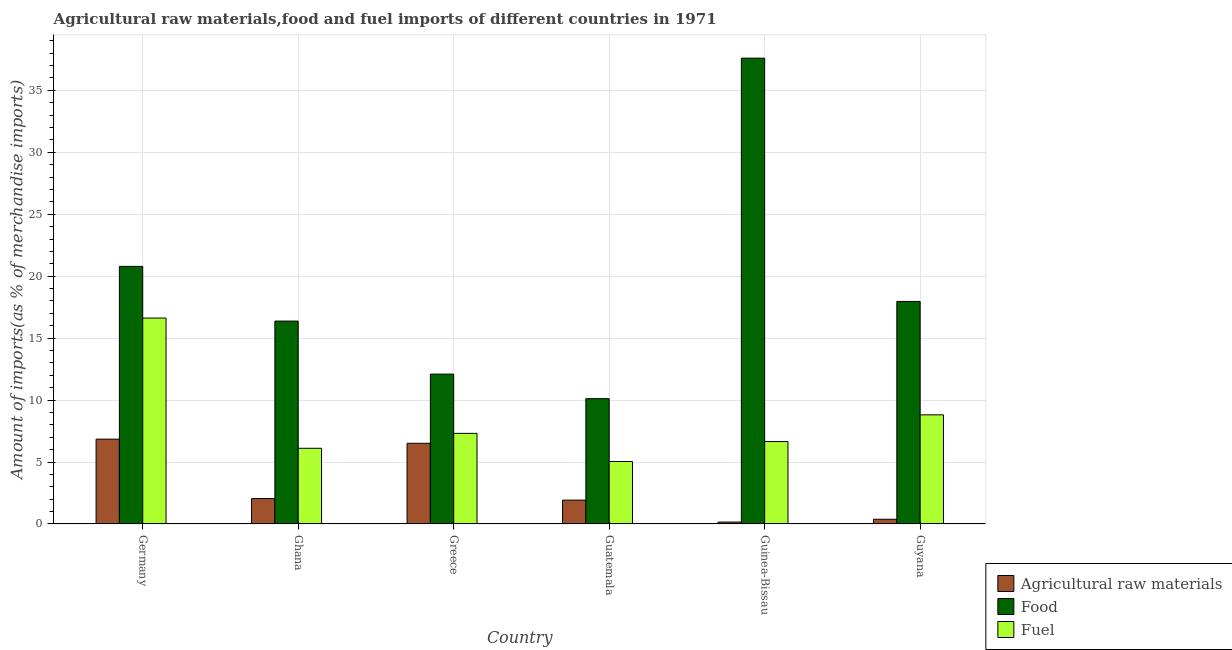How many bars are there on the 3rd tick from the left?
Give a very brief answer. 3. What is the label of the 2nd group of bars from the left?
Offer a very short reply. Ghana. What is the percentage of food imports in Guatemala?
Offer a terse response. 10.11. Across all countries, what is the maximum percentage of raw materials imports?
Offer a terse response. 6.85. Across all countries, what is the minimum percentage of fuel imports?
Your response must be concise. 5.04. In which country was the percentage of fuel imports maximum?
Keep it short and to the point. Germany. In which country was the percentage of fuel imports minimum?
Make the answer very short. Guatemala. What is the total percentage of food imports in the graph?
Make the answer very short. 114.93. What is the difference between the percentage of food imports in Ghana and that in Guinea-Bissau?
Ensure brevity in your answer.  -21.22. What is the difference between the percentage of raw materials imports in Ghana and the percentage of food imports in Guinea-Bissau?
Keep it short and to the point. -35.54. What is the average percentage of raw materials imports per country?
Ensure brevity in your answer.  2.98. What is the difference between the percentage of raw materials imports and percentage of food imports in Guinea-Bissau?
Offer a very short reply. -37.44. What is the ratio of the percentage of food imports in Guatemala to that in Guinea-Bissau?
Your answer should be compact. 0.27. Is the percentage of food imports in Guatemala less than that in Guyana?
Keep it short and to the point. Yes. What is the difference between the highest and the second highest percentage of food imports?
Keep it short and to the point. 16.81. What is the difference between the highest and the lowest percentage of fuel imports?
Provide a short and direct response. 11.58. In how many countries, is the percentage of fuel imports greater than the average percentage of fuel imports taken over all countries?
Give a very brief answer. 2. Is the sum of the percentage of fuel imports in Germany and Guyana greater than the maximum percentage of raw materials imports across all countries?
Offer a very short reply. Yes. What does the 2nd bar from the left in Greece represents?
Provide a succinct answer. Food. What does the 2nd bar from the right in Guyana represents?
Ensure brevity in your answer.  Food. How many bars are there?
Provide a succinct answer. 18. Are all the bars in the graph horizontal?
Offer a very short reply. No. How many countries are there in the graph?
Offer a terse response. 6. Does the graph contain grids?
Provide a succinct answer. Yes. How many legend labels are there?
Offer a very short reply. 3. How are the legend labels stacked?
Offer a very short reply. Vertical. What is the title of the graph?
Your answer should be very brief. Agricultural raw materials,food and fuel imports of different countries in 1971. Does "Profit Tax" appear as one of the legend labels in the graph?
Provide a succinct answer. No. What is the label or title of the X-axis?
Your response must be concise. Country. What is the label or title of the Y-axis?
Ensure brevity in your answer.  Amount of imports(as % of merchandise imports). What is the Amount of imports(as % of merchandise imports) of Agricultural raw materials in Germany?
Offer a terse response. 6.85. What is the Amount of imports(as % of merchandise imports) in Food in Germany?
Make the answer very short. 20.79. What is the Amount of imports(as % of merchandise imports) of Fuel in Germany?
Your answer should be compact. 16.62. What is the Amount of imports(as % of merchandise imports) of Agricultural raw materials in Ghana?
Provide a short and direct response. 2.05. What is the Amount of imports(as % of merchandise imports) in Food in Ghana?
Your answer should be compact. 16.38. What is the Amount of imports(as % of merchandise imports) in Fuel in Ghana?
Your response must be concise. 6.11. What is the Amount of imports(as % of merchandise imports) in Agricultural raw materials in Greece?
Provide a short and direct response. 6.51. What is the Amount of imports(as % of merchandise imports) in Food in Greece?
Provide a short and direct response. 12.09. What is the Amount of imports(as % of merchandise imports) in Fuel in Greece?
Ensure brevity in your answer.  7.31. What is the Amount of imports(as % of merchandise imports) in Agricultural raw materials in Guatemala?
Offer a terse response. 1.93. What is the Amount of imports(as % of merchandise imports) of Food in Guatemala?
Ensure brevity in your answer.  10.11. What is the Amount of imports(as % of merchandise imports) of Fuel in Guatemala?
Provide a succinct answer. 5.04. What is the Amount of imports(as % of merchandise imports) of Agricultural raw materials in Guinea-Bissau?
Provide a succinct answer. 0.15. What is the Amount of imports(as % of merchandise imports) of Food in Guinea-Bissau?
Make the answer very short. 37.6. What is the Amount of imports(as % of merchandise imports) in Fuel in Guinea-Bissau?
Give a very brief answer. 6.65. What is the Amount of imports(as % of merchandise imports) in Agricultural raw materials in Guyana?
Provide a succinct answer. 0.38. What is the Amount of imports(as % of merchandise imports) in Food in Guyana?
Keep it short and to the point. 17.96. What is the Amount of imports(as % of merchandise imports) of Fuel in Guyana?
Your response must be concise. 8.81. Across all countries, what is the maximum Amount of imports(as % of merchandise imports) of Agricultural raw materials?
Make the answer very short. 6.85. Across all countries, what is the maximum Amount of imports(as % of merchandise imports) of Food?
Provide a succinct answer. 37.6. Across all countries, what is the maximum Amount of imports(as % of merchandise imports) in Fuel?
Ensure brevity in your answer.  16.62. Across all countries, what is the minimum Amount of imports(as % of merchandise imports) in Agricultural raw materials?
Offer a very short reply. 0.15. Across all countries, what is the minimum Amount of imports(as % of merchandise imports) in Food?
Make the answer very short. 10.11. Across all countries, what is the minimum Amount of imports(as % of merchandise imports) of Fuel?
Your response must be concise. 5.04. What is the total Amount of imports(as % of merchandise imports) of Agricultural raw materials in the graph?
Give a very brief answer. 17.87. What is the total Amount of imports(as % of merchandise imports) in Food in the graph?
Make the answer very short. 114.93. What is the total Amount of imports(as % of merchandise imports) in Fuel in the graph?
Your answer should be very brief. 50.55. What is the difference between the Amount of imports(as % of merchandise imports) in Agricultural raw materials in Germany and that in Ghana?
Ensure brevity in your answer.  4.8. What is the difference between the Amount of imports(as % of merchandise imports) of Food in Germany and that in Ghana?
Provide a succinct answer. 4.41. What is the difference between the Amount of imports(as % of merchandise imports) of Fuel in Germany and that in Ghana?
Offer a very short reply. 10.51. What is the difference between the Amount of imports(as % of merchandise imports) in Agricultural raw materials in Germany and that in Greece?
Offer a terse response. 0.34. What is the difference between the Amount of imports(as % of merchandise imports) of Food in Germany and that in Greece?
Give a very brief answer. 8.7. What is the difference between the Amount of imports(as % of merchandise imports) in Fuel in Germany and that in Greece?
Ensure brevity in your answer.  9.31. What is the difference between the Amount of imports(as % of merchandise imports) of Agricultural raw materials in Germany and that in Guatemala?
Give a very brief answer. 4.92. What is the difference between the Amount of imports(as % of merchandise imports) of Food in Germany and that in Guatemala?
Your answer should be very brief. 10.68. What is the difference between the Amount of imports(as % of merchandise imports) in Fuel in Germany and that in Guatemala?
Ensure brevity in your answer.  11.58. What is the difference between the Amount of imports(as % of merchandise imports) of Agricultural raw materials in Germany and that in Guinea-Bissau?
Provide a short and direct response. 6.69. What is the difference between the Amount of imports(as % of merchandise imports) of Food in Germany and that in Guinea-Bissau?
Provide a short and direct response. -16.81. What is the difference between the Amount of imports(as % of merchandise imports) of Fuel in Germany and that in Guinea-Bissau?
Your answer should be compact. 9.97. What is the difference between the Amount of imports(as % of merchandise imports) of Agricultural raw materials in Germany and that in Guyana?
Ensure brevity in your answer.  6.47. What is the difference between the Amount of imports(as % of merchandise imports) of Food in Germany and that in Guyana?
Provide a short and direct response. 2.83. What is the difference between the Amount of imports(as % of merchandise imports) in Fuel in Germany and that in Guyana?
Your answer should be very brief. 7.81. What is the difference between the Amount of imports(as % of merchandise imports) in Agricultural raw materials in Ghana and that in Greece?
Give a very brief answer. -4.46. What is the difference between the Amount of imports(as % of merchandise imports) of Food in Ghana and that in Greece?
Offer a very short reply. 4.28. What is the difference between the Amount of imports(as % of merchandise imports) in Fuel in Ghana and that in Greece?
Provide a succinct answer. -1.2. What is the difference between the Amount of imports(as % of merchandise imports) of Agricultural raw materials in Ghana and that in Guatemala?
Provide a short and direct response. 0.13. What is the difference between the Amount of imports(as % of merchandise imports) of Food in Ghana and that in Guatemala?
Give a very brief answer. 6.26. What is the difference between the Amount of imports(as % of merchandise imports) of Fuel in Ghana and that in Guatemala?
Your answer should be compact. 1.07. What is the difference between the Amount of imports(as % of merchandise imports) in Agricultural raw materials in Ghana and that in Guinea-Bissau?
Your answer should be compact. 1.9. What is the difference between the Amount of imports(as % of merchandise imports) in Food in Ghana and that in Guinea-Bissau?
Your response must be concise. -21.22. What is the difference between the Amount of imports(as % of merchandise imports) of Fuel in Ghana and that in Guinea-Bissau?
Keep it short and to the point. -0.54. What is the difference between the Amount of imports(as % of merchandise imports) in Agricultural raw materials in Ghana and that in Guyana?
Make the answer very short. 1.67. What is the difference between the Amount of imports(as % of merchandise imports) of Food in Ghana and that in Guyana?
Give a very brief answer. -1.59. What is the difference between the Amount of imports(as % of merchandise imports) of Fuel in Ghana and that in Guyana?
Keep it short and to the point. -2.7. What is the difference between the Amount of imports(as % of merchandise imports) in Agricultural raw materials in Greece and that in Guatemala?
Your answer should be very brief. 4.59. What is the difference between the Amount of imports(as % of merchandise imports) in Food in Greece and that in Guatemala?
Offer a very short reply. 1.98. What is the difference between the Amount of imports(as % of merchandise imports) of Fuel in Greece and that in Guatemala?
Provide a short and direct response. 2.27. What is the difference between the Amount of imports(as % of merchandise imports) in Agricultural raw materials in Greece and that in Guinea-Bissau?
Offer a very short reply. 6.36. What is the difference between the Amount of imports(as % of merchandise imports) of Food in Greece and that in Guinea-Bissau?
Keep it short and to the point. -25.5. What is the difference between the Amount of imports(as % of merchandise imports) in Fuel in Greece and that in Guinea-Bissau?
Keep it short and to the point. 0.66. What is the difference between the Amount of imports(as % of merchandise imports) of Agricultural raw materials in Greece and that in Guyana?
Ensure brevity in your answer.  6.13. What is the difference between the Amount of imports(as % of merchandise imports) in Food in Greece and that in Guyana?
Provide a short and direct response. -5.87. What is the difference between the Amount of imports(as % of merchandise imports) of Fuel in Greece and that in Guyana?
Make the answer very short. -1.5. What is the difference between the Amount of imports(as % of merchandise imports) of Agricultural raw materials in Guatemala and that in Guinea-Bissau?
Your answer should be very brief. 1.77. What is the difference between the Amount of imports(as % of merchandise imports) of Food in Guatemala and that in Guinea-Bissau?
Give a very brief answer. -27.48. What is the difference between the Amount of imports(as % of merchandise imports) in Fuel in Guatemala and that in Guinea-Bissau?
Ensure brevity in your answer.  -1.61. What is the difference between the Amount of imports(as % of merchandise imports) of Agricultural raw materials in Guatemala and that in Guyana?
Your response must be concise. 1.55. What is the difference between the Amount of imports(as % of merchandise imports) in Food in Guatemala and that in Guyana?
Provide a succinct answer. -7.85. What is the difference between the Amount of imports(as % of merchandise imports) of Fuel in Guatemala and that in Guyana?
Make the answer very short. -3.77. What is the difference between the Amount of imports(as % of merchandise imports) of Agricultural raw materials in Guinea-Bissau and that in Guyana?
Your response must be concise. -0.23. What is the difference between the Amount of imports(as % of merchandise imports) in Food in Guinea-Bissau and that in Guyana?
Your answer should be very brief. 19.63. What is the difference between the Amount of imports(as % of merchandise imports) of Fuel in Guinea-Bissau and that in Guyana?
Your answer should be very brief. -2.16. What is the difference between the Amount of imports(as % of merchandise imports) of Agricultural raw materials in Germany and the Amount of imports(as % of merchandise imports) of Food in Ghana?
Your response must be concise. -9.53. What is the difference between the Amount of imports(as % of merchandise imports) in Agricultural raw materials in Germany and the Amount of imports(as % of merchandise imports) in Fuel in Ghana?
Offer a very short reply. 0.74. What is the difference between the Amount of imports(as % of merchandise imports) in Food in Germany and the Amount of imports(as % of merchandise imports) in Fuel in Ghana?
Give a very brief answer. 14.68. What is the difference between the Amount of imports(as % of merchandise imports) in Agricultural raw materials in Germany and the Amount of imports(as % of merchandise imports) in Food in Greece?
Make the answer very short. -5.25. What is the difference between the Amount of imports(as % of merchandise imports) of Agricultural raw materials in Germany and the Amount of imports(as % of merchandise imports) of Fuel in Greece?
Your answer should be compact. -0.47. What is the difference between the Amount of imports(as % of merchandise imports) of Food in Germany and the Amount of imports(as % of merchandise imports) of Fuel in Greece?
Give a very brief answer. 13.48. What is the difference between the Amount of imports(as % of merchandise imports) of Agricultural raw materials in Germany and the Amount of imports(as % of merchandise imports) of Food in Guatemala?
Provide a short and direct response. -3.27. What is the difference between the Amount of imports(as % of merchandise imports) in Agricultural raw materials in Germany and the Amount of imports(as % of merchandise imports) in Fuel in Guatemala?
Make the answer very short. 1.8. What is the difference between the Amount of imports(as % of merchandise imports) in Food in Germany and the Amount of imports(as % of merchandise imports) in Fuel in Guatemala?
Offer a very short reply. 15.75. What is the difference between the Amount of imports(as % of merchandise imports) in Agricultural raw materials in Germany and the Amount of imports(as % of merchandise imports) in Food in Guinea-Bissau?
Offer a very short reply. -30.75. What is the difference between the Amount of imports(as % of merchandise imports) of Agricultural raw materials in Germany and the Amount of imports(as % of merchandise imports) of Fuel in Guinea-Bissau?
Offer a terse response. 0.19. What is the difference between the Amount of imports(as % of merchandise imports) of Food in Germany and the Amount of imports(as % of merchandise imports) of Fuel in Guinea-Bissau?
Offer a terse response. 14.14. What is the difference between the Amount of imports(as % of merchandise imports) of Agricultural raw materials in Germany and the Amount of imports(as % of merchandise imports) of Food in Guyana?
Provide a succinct answer. -11.11. What is the difference between the Amount of imports(as % of merchandise imports) in Agricultural raw materials in Germany and the Amount of imports(as % of merchandise imports) in Fuel in Guyana?
Offer a terse response. -1.96. What is the difference between the Amount of imports(as % of merchandise imports) of Food in Germany and the Amount of imports(as % of merchandise imports) of Fuel in Guyana?
Keep it short and to the point. 11.98. What is the difference between the Amount of imports(as % of merchandise imports) of Agricultural raw materials in Ghana and the Amount of imports(as % of merchandise imports) of Food in Greece?
Ensure brevity in your answer.  -10.04. What is the difference between the Amount of imports(as % of merchandise imports) in Agricultural raw materials in Ghana and the Amount of imports(as % of merchandise imports) in Fuel in Greece?
Give a very brief answer. -5.26. What is the difference between the Amount of imports(as % of merchandise imports) of Food in Ghana and the Amount of imports(as % of merchandise imports) of Fuel in Greece?
Your answer should be very brief. 9.06. What is the difference between the Amount of imports(as % of merchandise imports) in Agricultural raw materials in Ghana and the Amount of imports(as % of merchandise imports) in Food in Guatemala?
Keep it short and to the point. -8.06. What is the difference between the Amount of imports(as % of merchandise imports) of Agricultural raw materials in Ghana and the Amount of imports(as % of merchandise imports) of Fuel in Guatemala?
Your response must be concise. -2.99. What is the difference between the Amount of imports(as % of merchandise imports) of Food in Ghana and the Amount of imports(as % of merchandise imports) of Fuel in Guatemala?
Offer a terse response. 11.33. What is the difference between the Amount of imports(as % of merchandise imports) of Agricultural raw materials in Ghana and the Amount of imports(as % of merchandise imports) of Food in Guinea-Bissau?
Offer a terse response. -35.54. What is the difference between the Amount of imports(as % of merchandise imports) in Agricultural raw materials in Ghana and the Amount of imports(as % of merchandise imports) in Fuel in Guinea-Bissau?
Offer a very short reply. -4.6. What is the difference between the Amount of imports(as % of merchandise imports) of Food in Ghana and the Amount of imports(as % of merchandise imports) of Fuel in Guinea-Bissau?
Provide a succinct answer. 9.72. What is the difference between the Amount of imports(as % of merchandise imports) in Agricultural raw materials in Ghana and the Amount of imports(as % of merchandise imports) in Food in Guyana?
Provide a short and direct response. -15.91. What is the difference between the Amount of imports(as % of merchandise imports) in Agricultural raw materials in Ghana and the Amount of imports(as % of merchandise imports) in Fuel in Guyana?
Your answer should be compact. -6.76. What is the difference between the Amount of imports(as % of merchandise imports) in Food in Ghana and the Amount of imports(as % of merchandise imports) in Fuel in Guyana?
Your response must be concise. 7.57. What is the difference between the Amount of imports(as % of merchandise imports) in Agricultural raw materials in Greece and the Amount of imports(as % of merchandise imports) in Food in Guatemala?
Keep it short and to the point. -3.6. What is the difference between the Amount of imports(as % of merchandise imports) of Agricultural raw materials in Greece and the Amount of imports(as % of merchandise imports) of Fuel in Guatemala?
Your answer should be compact. 1.47. What is the difference between the Amount of imports(as % of merchandise imports) in Food in Greece and the Amount of imports(as % of merchandise imports) in Fuel in Guatemala?
Offer a very short reply. 7.05. What is the difference between the Amount of imports(as % of merchandise imports) in Agricultural raw materials in Greece and the Amount of imports(as % of merchandise imports) in Food in Guinea-Bissau?
Give a very brief answer. -31.08. What is the difference between the Amount of imports(as % of merchandise imports) in Agricultural raw materials in Greece and the Amount of imports(as % of merchandise imports) in Fuel in Guinea-Bissau?
Keep it short and to the point. -0.14. What is the difference between the Amount of imports(as % of merchandise imports) of Food in Greece and the Amount of imports(as % of merchandise imports) of Fuel in Guinea-Bissau?
Offer a terse response. 5.44. What is the difference between the Amount of imports(as % of merchandise imports) in Agricultural raw materials in Greece and the Amount of imports(as % of merchandise imports) in Food in Guyana?
Offer a very short reply. -11.45. What is the difference between the Amount of imports(as % of merchandise imports) in Agricultural raw materials in Greece and the Amount of imports(as % of merchandise imports) in Fuel in Guyana?
Your response must be concise. -2.3. What is the difference between the Amount of imports(as % of merchandise imports) of Food in Greece and the Amount of imports(as % of merchandise imports) of Fuel in Guyana?
Make the answer very short. 3.29. What is the difference between the Amount of imports(as % of merchandise imports) in Agricultural raw materials in Guatemala and the Amount of imports(as % of merchandise imports) in Food in Guinea-Bissau?
Keep it short and to the point. -35.67. What is the difference between the Amount of imports(as % of merchandise imports) of Agricultural raw materials in Guatemala and the Amount of imports(as % of merchandise imports) of Fuel in Guinea-Bissau?
Your answer should be compact. -4.73. What is the difference between the Amount of imports(as % of merchandise imports) in Food in Guatemala and the Amount of imports(as % of merchandise imports) in Fuel in Guinea-Bissau?
Your answer should be very brief. 3.46. What is the difference between the Amount of imports(as % of merchandise imports) in Agricultural raw materials in Guatemala and the Amount of imports(as % of merchandise imports) in Food in Guyana?
Give a very brief answer. -16.04. What is the difference between the Amount of imports(as % of merchandise imports) in Agricultural raw materials in Guatemala and the Amount of imports(as % of merchandise imports) in Fuel in Guyana?
Your response must be concise. -6.88. What is the difference between the Amount of imports(as % of merchandise imports) in Food in Guatemala and the Amount of imports(as % of merchandise imports) in Fuel in Guyana?
Provide a succinct answer. 1.3. What is the difference between the Amount of imports(as % of merchandise imports) in Agricultural raw materials in Guinea-Bissau and the Amount of imports(as % of merchandise imports) in Food in Guyana?
Give a very brief answer. -17.81. What is the difference between the Amount of imports(as % of merchandise imports) of Agricultural raw materials in Guinea-Bissau and the Amount of imports(as % of merchandise imports) of Fuel in Guyana?
Keep it short and to the point. -8.65. What is the difference between the Amount of imports(as % of merchandise imports) of Food in Guinea-Bissau and the Amount of imports(as % of merchandise imports) of Fuel in Guyana?
Provide a short and direct response. 28.79. What is the average Amount of imports(as % of merchandise imports) of Agricultural raw materials per country?
Provide a short and direct response. 2.98. What is the average Amount of imports(as % of merchandise imports) of Food per country?
Offer a very short reply. 19.16. What is the average Amount of imports(as % of merchandise imports) in Fuel per country?
Offer a very short reply. 8.42. What is the difference between the Amount of imports(as % of merchandise imports) of Agricultural raw materials and Amount of imports(as % of merchandise imports) of Food in Germany?
Give a very brief answer. -13.94. What is the difference between the Amount of imports(as % of merchandise imports) in Agricultural raw materials and Amount of imports(as % of merchandise imports) in Fuel in Germany?
Provide a succinct answer. -9.77. What is the difference between the Amount of imports(as % of merchandise imports) of Food and Amount of imports(as % of merchandise imports) of Fuel in Germany?
Provide a short and direct response. 4.17. What is the difference between the Amount of imports(as % of merchandise imports) in Agricultural raw materials and Amount of imports(as % of merchandise imports) in Food in Ghana?
Make the answer very short. -14.32. What is the difference between the Amount of imports(as % of merchandise imports) of Agricultural raw materials and Amount of imports(as % of merchandise imports) of Fuel in Ghana?
Give a very brief answer. -4.06. What is the difference between the Amount of imports(as % of merchandise imports) in Food and Amount of imports(as % of merchandise imports) in Fuel in Ghana?
Ensure brevity in your answer.  10.27. What is the difference between the Amount of imports(as % of merchandise imports) of Agricultural raw materials and Amount of imports(as % of merchandise imports) of Food in Greece?
Give a very brief answer. -5.58. What is the difference between the Amount of imports(as % of merchandise imports) of Agricultural raw materials and Amount of imports(as % of merchandise imports) of Fuel in Greece?
Give a very brief answer. -0.8. What is the difference between the Amount of imports(as % of merchandise imports) in Food and Amount of imports(as % of merchandise imports) in Fuel in Greece?
Provide a short and direct response. 4.78. What is the difference between the Amount of imports(as % of merchandise imports) in Agricultural raw materials and Amount of imports(as % of merchandise imports) in Food in Guatemala?
Offer a very short reply. -8.19. What is the difference between the Amount of imports(as % of merchandise imports) of Agricultural raw materials and Amount of imports(as % of merchandise imports) of Fuel in Guatemala?
Ensure brevity in your answer.  -3.12. What is the difference between the Amount of imports(as % of merchandise imports) in Food and Amount of imports(as % of merchandise imports) in Fuel in Guatemala?
Provide a succinct answer. 5.07. What is the difference between the Amount of imports(as % of merchandise imports) of Agricultural raw materials and Amount of imports(as % of merchandise imports) of Food in Guinea-Bissau?
Your answer should be very brief. -37.44. What is the difference between the Amount of imports(as % of merchandise imports) of Agricultural raw materials and Amount of imports(as % of merchandise imports) of Fuel in Guinea-Bissau?
Provide a short and direct response. -6.5. What is the difference between the Amount of imports(as % of merchandise imports) of Food and Amount of imports(as % of merchandise imports) of Fuel in Guinea-Bissau?
Keep it short and to the point. 30.94. What is the difference between the Amount of imports(as % of merchandise imports) in Agricultural raw materials and Amount of imports(as % of merchandise imports) in Food in Guyana?
Offer a terse response. -17.58. What is the difference between the Amount of imports(as % of merchandise imports) of Agricultural raw materials and Amount of imports(as % of merchandise imports) of Fuel in Guyana?
Provide a succinct answer. -8.43. What is the difference between the Amount of imports(as % of merchandise imports) of Food and Amount of imports(as % of merchandise imports) of Fuel in Guyana?
Offer a very short reply. 9.15. What is the ratio of the Amount of imports(as % of merchandise imports) in Agricultural raw materials in Germany to that in Ghana?
Ensure brevity in your answer.  3.34. What is the ratio of the Amount of imports(as % of merchandise imports) of Food in Germany to that in Ghana?
Your answer should be compact. 1.27. What is the ratio of the Amount of imports(as % of merchandise imports) in Fuel in Germany to that in Ghana?
Your answer should be very brief. 2.72. What is the ratio of the Amount of imports(as % of merchandise imports) in Agricultural raw materials in Germany to that in Greece?
Your response must be concise. 1.05. What is the ratio of the Amount of imports(as % of merchandise imports) of Food in Germany to that in Greece?
Provide a short and direct response. 1.72. What is the ratio of the Amount of imports(as % of merchandise imports) in Fuel in Germany to that in Greece?
Ensure brevity in your answer.  2.27. What is the ratio of the Amount of imports(as % of merchandise imports) in Agricultural raw materials in Germany to that in Guatemala?
Offer a very short reply. 3.55. What is the ratio of the Amount of imports(as % of merchandise imports) in Food in Germany to that in Guatemala?
Provide a succinct answer. 2.06. What is the ratio of the Amount of imports(as % of merchandise imports) of Fuel in Germany to that in Guatemala?
Your response must be concise. 3.3. What is the ratio of the Amount of imports(as % of merchandise imports) in Agricultural raw materials in Germany to that in Guinea-Bissau?
Provide a succinct answer. 44.29. What is the ratio of the Amount of imports(as % of merchandise imports) of Food in Germany to that in Guinea-Bissau?
Make the answer very short. 0.55. What is the ratio of the Amount of imports(as % of merchandise imports) of Fuel in Germany to that in Guinea-Bissau?
Offer a terse response. 2.5. What is the ratio of the Amount of imports(as % of merchandise imports) of Agricultural raw materials in Germany to that in Guyana?
Offer a terse response. 17.97. What is the ratio of the Amount of imports(as % of merchandise imports) of Food in Germany to that in Guyana?
Give a very brief answer. 1.16. What is the ratio of the Amount of imports(as % of merchandise imports) of Fuel in Germany to that in Guyana?
Provide a succinct answer. 1.89. What is the ratio of the Amount of imports(as % of merchandise imports) of Agricultural raw materials in Ghana to that in Greece?
Offer a very short reply. 0.32. What is the ratio of the Amount of imports(as % of merchandise imports) of Food in Ghana to that in Greece?
Your answer should be very brief. 1.35. What is the ratio of the Amount of imports(as % of merchandise imports) of Fuel in Ghana to that in Greece?
Make the answer very short. 0.84. What is the ratio of the Amount of imports(as % of merchandise imports) of Agricultural raw materials in Ghana to that in Guatemala?
Offer a terse response. 1.06. What is the ratio of the Amount of imports(as % of merchandise imports) of Food in Ghana to that in Guatemala?
Offer a very short reply. 1.62. What is the ratio of the Amount of imports(as % of merchandise imports) of Fuel in Ghana to that in Guatemala?
Offer a terse response. 1.21. What is the ratio of the Amount of imports(as % of merchandise imports) in Agricultural raw materials in Ghana to that in Guinea-Bissau?
Provide a succinct answer. 13.27. What is the ratio of the Amount of imports(as % of merchandise imports) in Food in Ghana to that in Guinea-Bissau?
Provide a short and direct response. 0.44. What is the ratio of the Amount of imports(as % of merchandise imports) in Fuel in Ghana to that in Guinea-Bissau?
Offer a very short reply. 0.92. What is the ratio of the Amount of imports(as % of merchandise imports) of Agricultural raw materials in Ghana to that in Guyana?
Make the answer very short. 5.38. What is the ratio of the Amount of imports(as % of merchandise imports) in Food in Ghana to that in Guyana?
Provide a succinct answer. 0.91. What is the ratio of the Amount of imports(as % of merchandise imports) in Fuel in Ghana to that in Guyana?
Make the answer very short. 0.69. What is the ratio of the Amount of imports(as % of merchandise imports) of Agricultural raw materials in Greece to that in Guatemala?
Provide a short and direct response. 3.38. What is the ratio of the Amount of imports(as % of merchandise imports) in Food in Greece to that in Guatemala?
Keep it short and to the point. 1.2. What is the ratio of the Amount of imports(as % of merchandise imports) of Fuel in Greece to that in Guatemala?
Offer a terse response. 1.45. What is the ratio of the Amount of imports(as % of merchandise imports) of Agricultural raw materials in Greece to that in Guinea-Bissau?
Your answer should be very brief. 42.12. What is the ratio of the Amount of imports(as % of merchandise imports) of Food in Greece to that in Guinea-Bissau?
Your answer should be very brief. 0.32. What is the ratio of the Amount of imports(as % of merchandise imports) of Fuel in Greece to that in Guinea-Bissau?
Ensure brevity in your answer.  1.1. What is the ratio of the Amount of imports(as % of merchandise imports) of Agricultural raw materials in Greece to that in Guyana?
Provide a succinct answer. 17.09. What is the ratio of the Amount of imports(as % of merchandise imports) of Food in Greece to that in Guyana?
Offer a very short reply. 0.67. What is the ratio of the Amount of imports(as % of merchandise imports) of Fuel in Greece to that in Guyana?
Make the answer very short. 0.83. What is the ratio of the Amount of imports(as % of merchandise imports) of Agricultural raw materials in Guatemala to that in Guinea-Bissau?
Provide a succinct answer. 12.46. What is the ratio of the Amount of imports(as % of merchandise imports) of Food in Guatemala to that in Guinea-Bissau?
Ensure brevity in your answer.  0.27. What is the ratio of the Amount of imports(as % of merchandise imports) of Fuel in Guatemala to that in Guinea-Bissau?
Keep it short and to the point. 0.76. What is the ratio of the Amount of imports(as % of merchandise imports) in Agricultural raw materials in Guatemala to that in Guyana?
Make the answer very short. 5.06. What is the ratio of the Amount of imports(as % of merchandise imports) in Food in Guatemala to that in Guyana?
Offer a very short reply. 0.56. What is the ratio of the Amount of imports(as % of merchandise imports) in Fuel in Guatemala to that in Guyana?
Ensure brevity in your answer.  0.57. What is the ratio of the Amount of imports(as % of merchandise imports) of Agricultural raw materials in Guinea-Bissau to that in Guyana?
Offer a very short reply. 0.41. What is the ratio of the Amount of imports(as % of merchandise imports) of Food in Guinea-Bissau to that in Guyana?
Make the answer very short. 2.09. What is the ratio of the Amount of imports(as % of merchandise imports) in Fuel in Guinea-Bissau to that in Guyana?
Your answer should be compact. 0.76. What is the difference between the highest and the second highest Amount of imports(as % of merchandise imports) of Agricultural raw materials?
Provide a short and direct response. 0.34. What is the difference between the highest and the second highest Amount of imports(as % of merchandise imports) of Food?
Make the answer very short. 16.81. What is the difference between the highest and the second highest Amount of imports(as % of merchandise imports) of Fuel?
Keep it short and to the point. 7.81. What is the difference between the highest and the lowest Amount of imports(as % of merchandise imports) in Agricultural raw materials?
Keep it short and to the point. 6.69. What is the difference between the highest and the lowest Amount of imports(as % of merchandise imports) in Food?
Ensure brevity in your answer.  27.48. What is the difference between the highest and the lowest Amount of imports(as % of merchandise imports) in Fuel?
Your answer should be very brief. 11.58. 